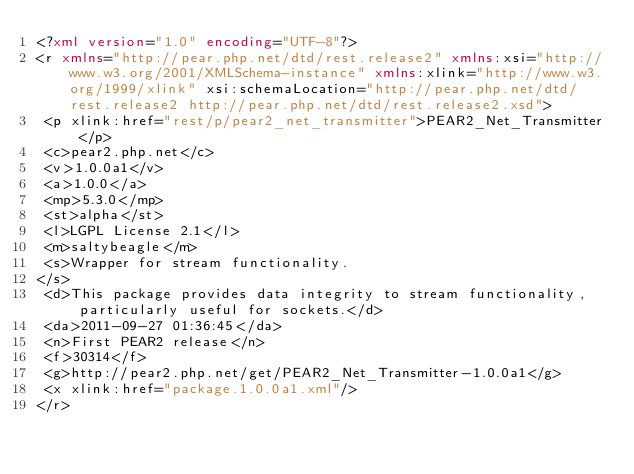<code> <loc_0><loc_0><loc_500><loc_500><_XML_><?xml version="1.0" encoding="UTF-8"?>
<r xmlns="http://pear.php.net/dtd/rest.release2" xmlns:xsi="http://www.w3.org/2001/XMLSchema-instance" xmlns:xlink="http://www.w3.org/1999/xlink" xsi:schemaLocation="http://pear.php.net/dtd/rest.release2 http://pear.php.net/dtd/rest.release2.xsd">
 <p xlink:href="rest/p/pear2_net_transmitter">PEAR2_Net_Transmitter</p>
 <c>pear2.php.net</c>
 <v>1.0.0a1</v>
 <a>1.0.0</a>
 <mp>5.3.0</mp>
 <st>alpha</st>
 <l>LGPL License 2.1</l>
 <m>saltybeagle</m>
 <s>Wrapper for stream functionality.
</s>
 <d>This package provides data integrity to stream functionality, particularly useful for sockets.</d>
 <da>2011-09-27 01:36:45</da>
 <n>First PEAR2 release</n>
 <f>30314</f>
 <g>http://pear2.php.net/get/PEAR2_Net_Transmitter-1.0.0a1</g>
 <x xlink:href="package.1.0.0a1.xml"/>
</r>
</code> 